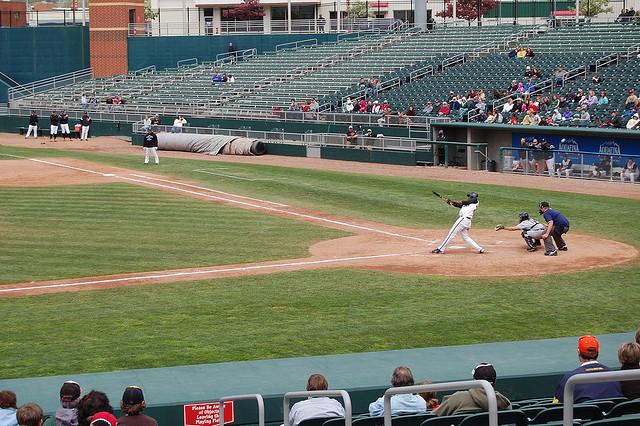What sport is being played?
Concise answer only. Baseball. What color cap is the man in the right foreground wearing?
Give a very brief answer. Red. Is the game very well attended?
Answer briefly. No. Who is winning?
Write a very short answer. White team. 